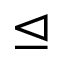<formula> <loc_0><loc_0><loc_500><loc_500>\triangleleft e q</formula> 